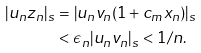<formula> <loc_0><loc_0><loc_500><loc_500>| u _ { n } z _ { n } | _ { s } & = | u _ { n } v _ { n } ( 1 + c _ { m } x _ { n } ) | _ { s } \\ & < \epsilon _ { n } | u _ { n } v _ { n } | _ { s } < 1 / n .</formula> 